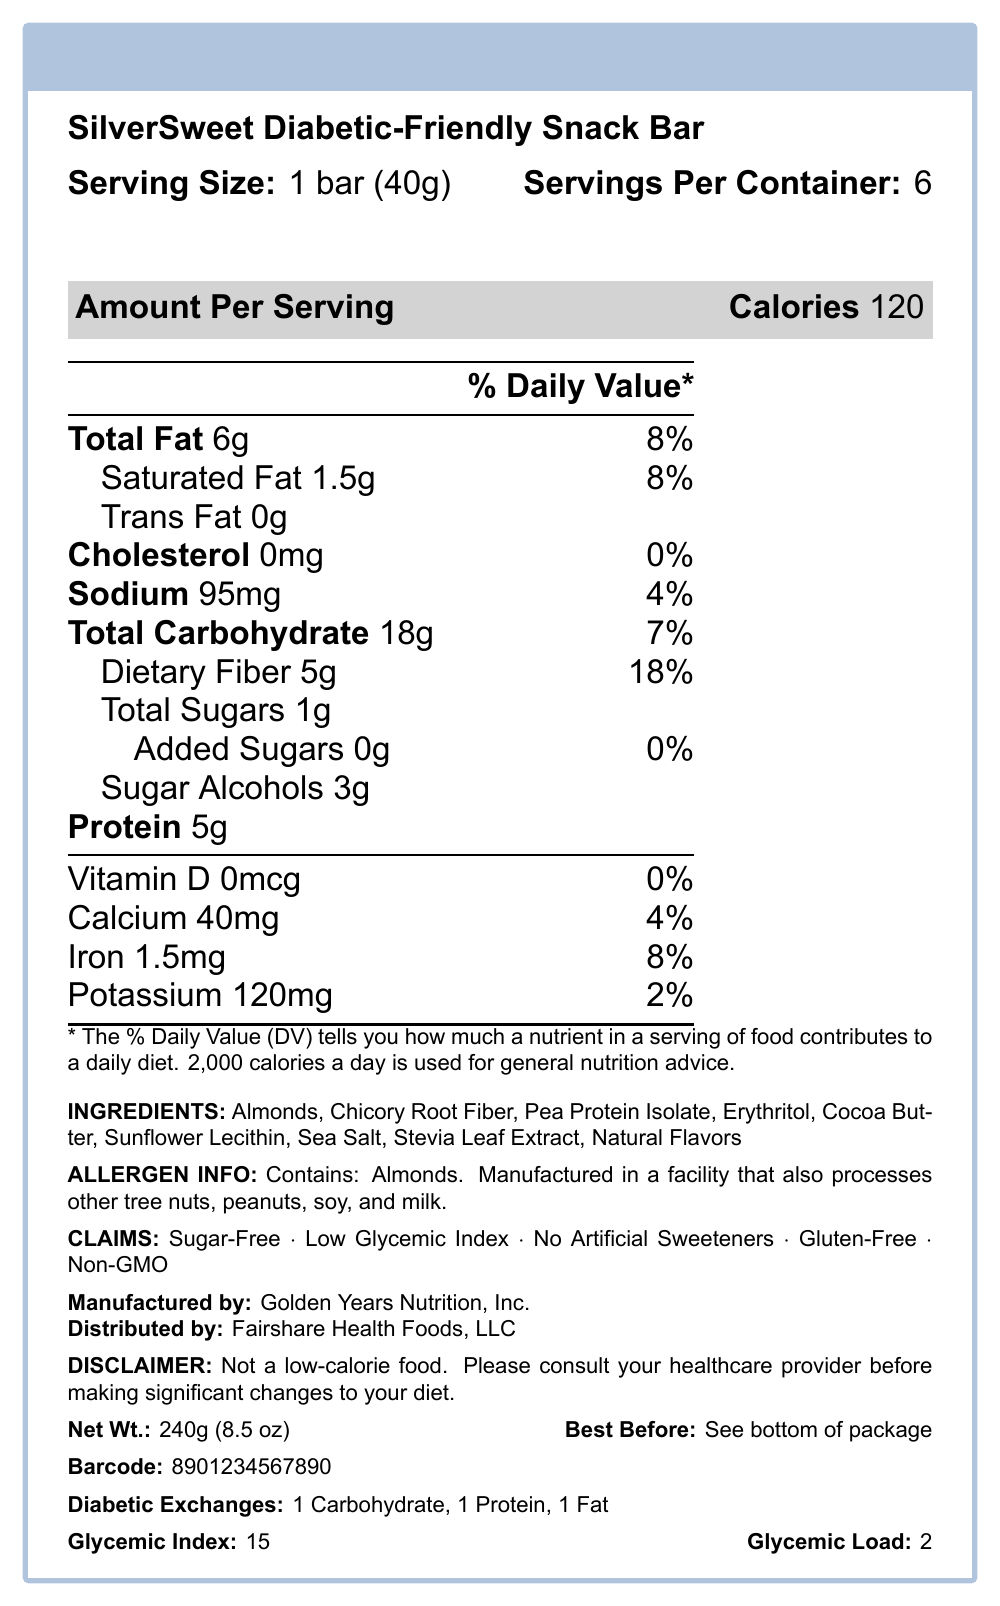What is the serving size for the SilverSweet Diabetic-Friendly Snack Bar? The serving size is explicitly listed as "1 bar (40g)" in the Nutrition Facts section.
Answer: 1 bar (40g) What is the total amount of dietary fiber per serving? According to the Nutrition Facts, the total dietary fiber per serving is 5g.
Answer: 5g What ingredients are used in the SilverSweet Diabetic-Friendly Snack Bar? The ingredients are listed at the bottom of the Nutrition Facts section.
Answer: Almonds, Chicory Root Fiber, Pea Protein Isolate, Erythritol, Cocoa Butter, Sunflower Lecithin, Sea Salt, Stevia Leaf Extract, Natural Flavors Which company manufactures the SilverSweet Diabetic-Friendly Snack Bar? The manufacturer is stated as "Golden Years Nutrition, Inc." near the bottom of the document.
Answer: Golden Years Nutrition, Inc. How many calories are there per serving? The document states that there are 120 calories per serving.
Answer: 120 What percentage of the daily value of iron does one serving provide? The Nutrition Facts indicate that one serving provides 8% of the daily value for iron.
Answer: 8% Which of the following is NOT a claim made for the SilverSweet Diabetic-Friendly Snack Bar? A. Sugar-Free B. Low Glycemic Index C. Contains Artificial Sweeteners D. Gluten-Free E. Non-GMO The claims section lists "No Artificial Sweeteners", so option C is incorrect.
Answer: C What is the glycemic index of the snack bar? A. 10 B. 15 C. 20 D. 25 The document lists the glycemic index as 15, making option B correct.
Answer: B Does the snack bar contain any cholesterol? The Nutrition Facts state that there is 0mg of cholesterol per serving.
Answer: No Summarize the main claims and nutritional highlights of the SilverSweet Diabetic-Friendly Snack Bar. The summary covers the key nutritional facts, health claims, and ingredient list presented in the document.
Answer: The SilverSweet Diabetic-Friendly Snack Bar has 120 calories per serving, with 6g of total fat, 18g of total carbohydrates, 5g of dietary fiber, and 5g of protein. It is sugar-free, has a low glycemic index of 15, and contains no artificial sweeteners. It is also gluten-free and non-GMO. The primary ingredients include almonds, chicory root fiber, pea protein isolate, and erythritol. The snack bar is manufactured by Golden Years Nutrition, Inc. How many grams of added sugars does the snack bar contain? The Nutrition Facts state that there are 0g of added sugars per serving.
Answer: 0g Is the snack bar considered low-calorie? The disclaimer at the end of the document explicitly states that it's not a low-calorie food.
Answer: No How many servings are there per container? The document states that there are 6 servings per container.
Answer: 6 What is the net weight of the entire package? The net weight is listed as 240g (8.5 oz) at the bottom of the document.
Answer: 240g (8.5 oz) What are the allergen information details for the snack bar? The allergen information section explicitly lists these details.
Answer: Contains: Almonds. Manufactured in a facility that also processes other tree nuts, peanuts, soy, and milk. How many grams of saturated fat does the snack bar have per serving? The document states that each serving contains 1.5g of saturated fat.
Answer: 1.5g What are the diabetic exchanges for the snack bar? The diabetic exchanges are listed as 1 Carbohydrate, 1 Protein, and 1 Fat at the bottom of the document.
Answer: 1 Carbohydrate, 1 Protein, 1 Fat What is the best before date for the snack bar? The document indicates that the best before date is given at the bottom of the package.
Answer: See bottom of package Does the snack bar contain cocoa? The ingredients list includes "Cocoa Butter", but it's unclear if it contains cocoa itself.
Answer: Not enough information 